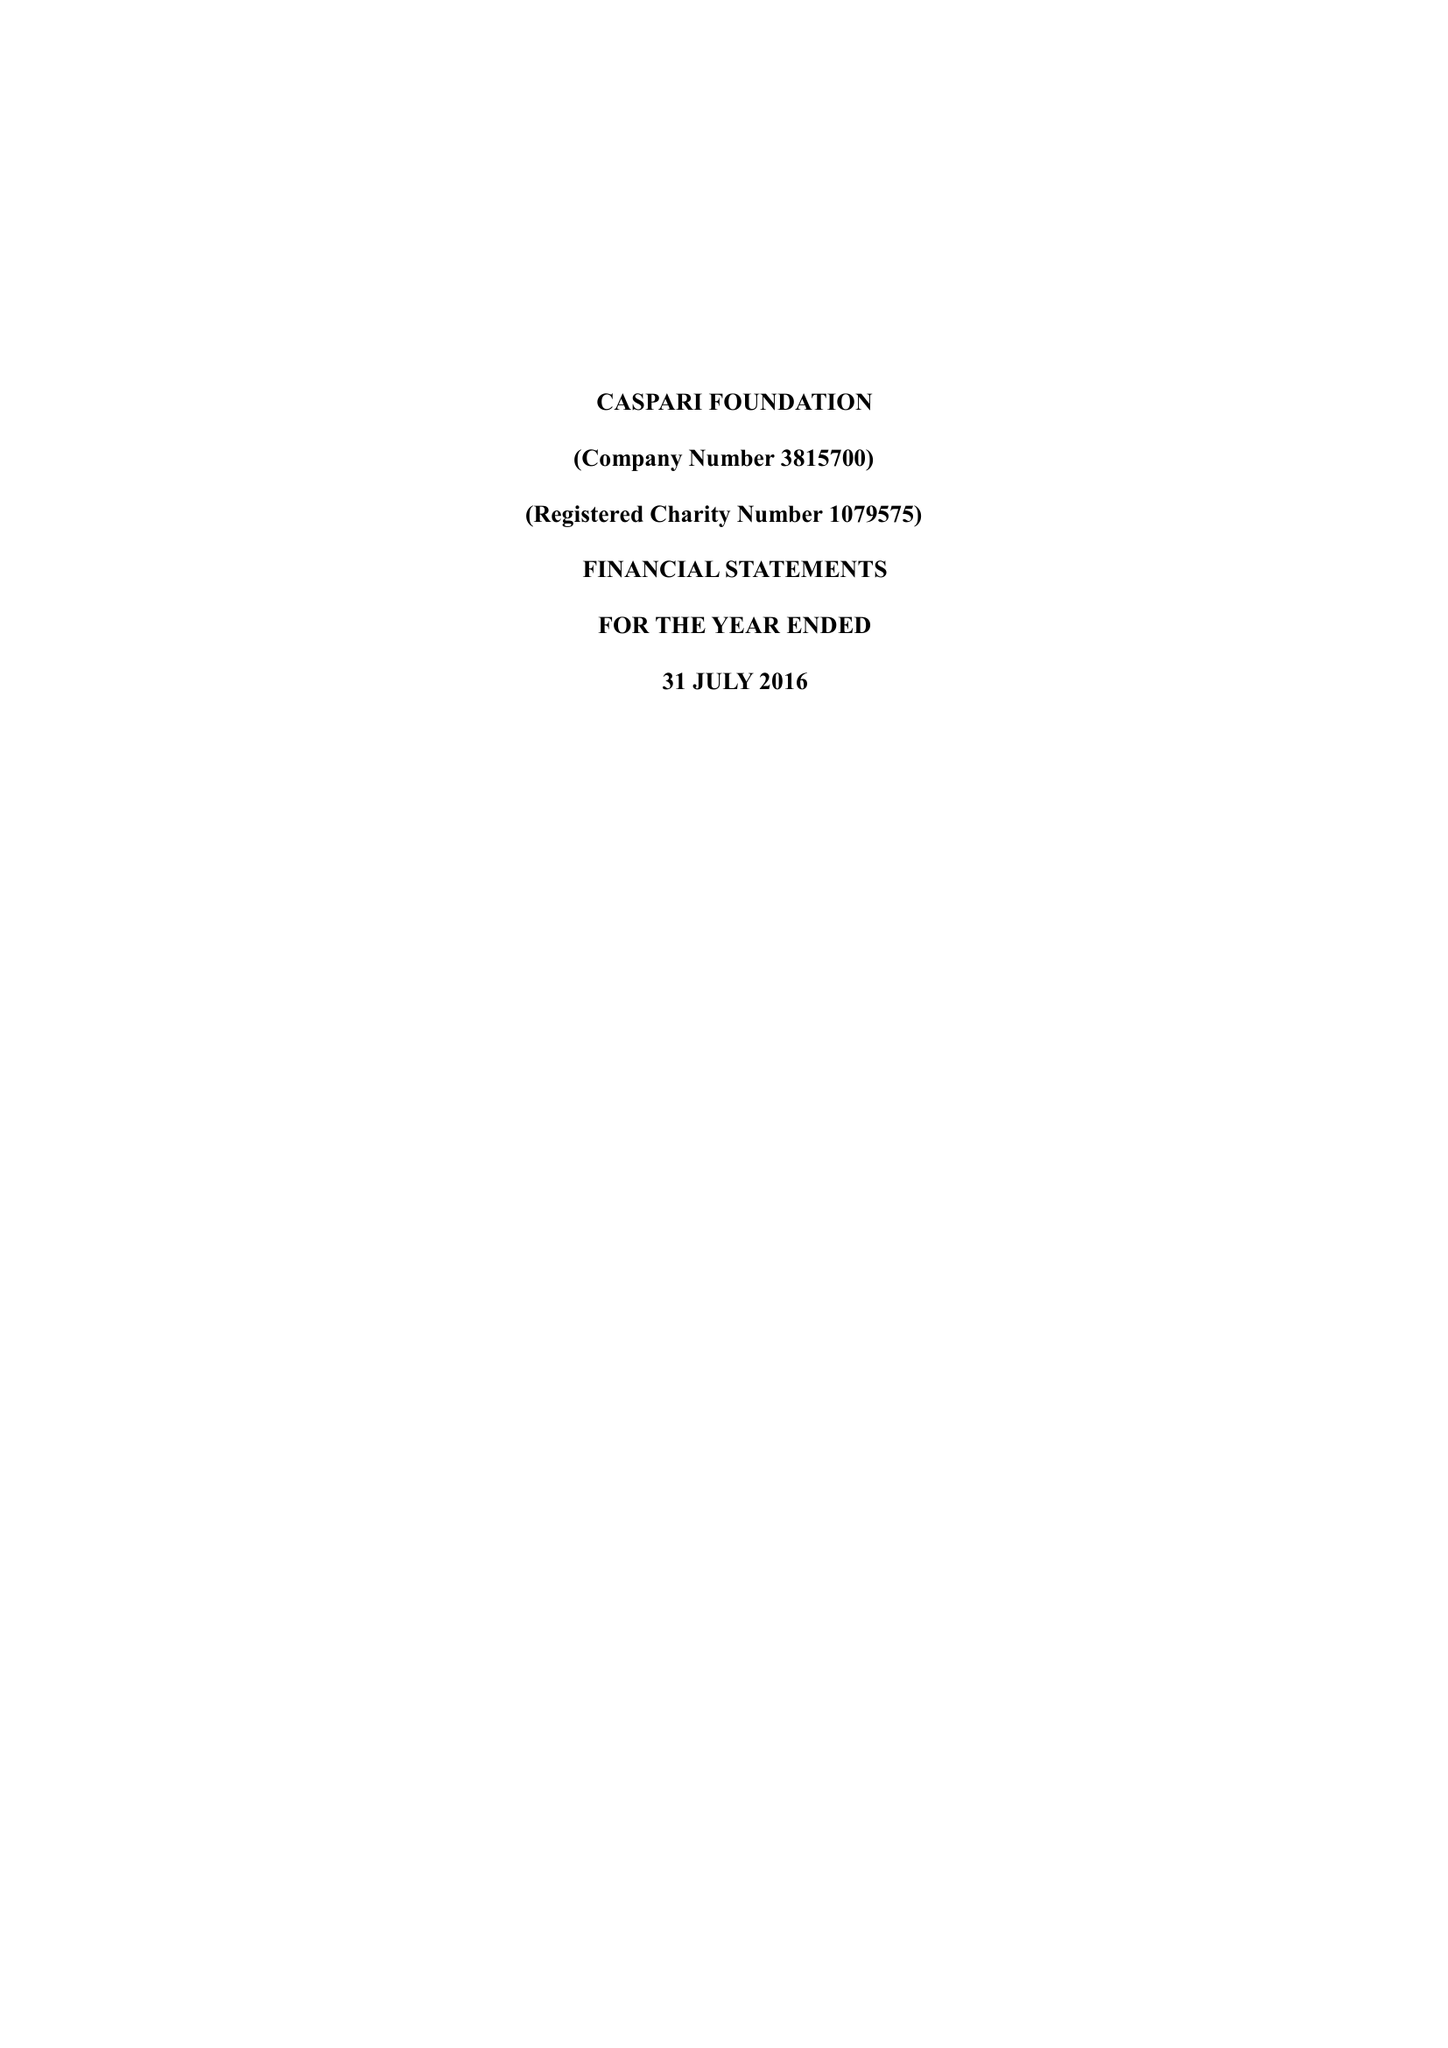What is the value for the address__post_town?
Answer the question using a single word or phrase. LONDON 